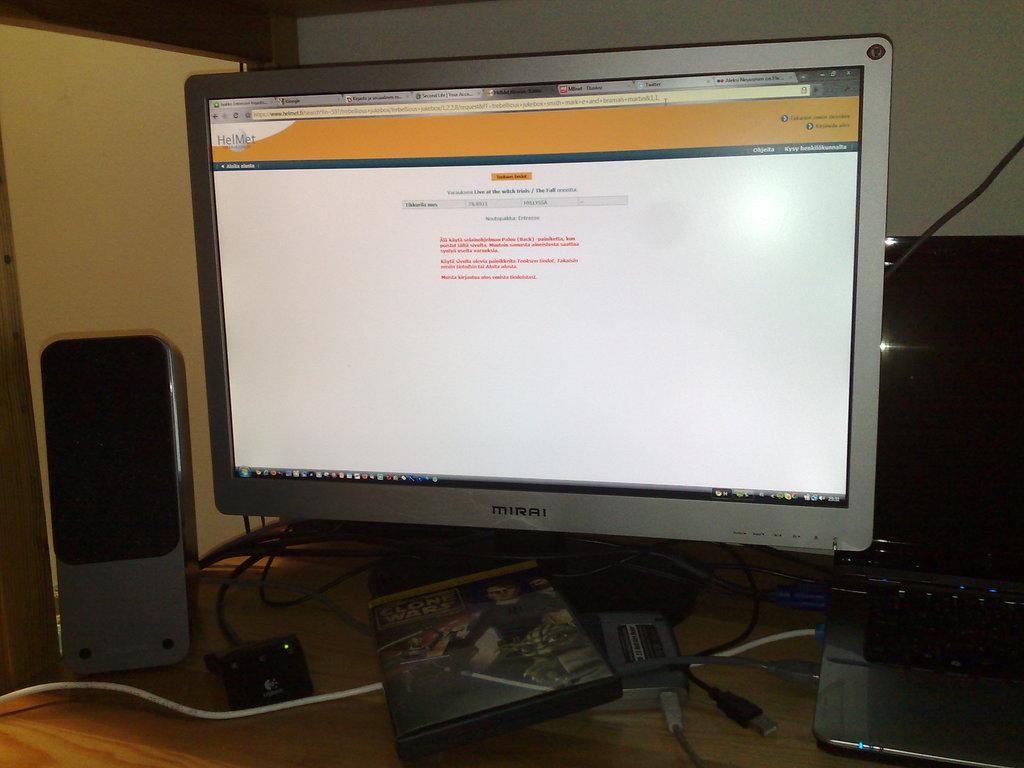What electronic device is present in the image? There is a monitor in the image. What is being displayed on the monitor? There are tabs opened on the monitor, and a website is visible on the screen. What audio device is present in the image? There is a speaker in the image. What type of computer is visible in the image? There is a laptop in the image. Are there any visible connections in the image? Yes, there are wires visible in the image. Can you describe the unspecified object in the image? Unfortunately, the description of the unspecified object is not provided in the facts. What type of yoke is connected to the laptop in the image? There is no yoke present in the image, and therefore no such connection can be observed. What kind of bird can be seen flying across the screen on the monitor? There is no bird visible on the screen or in the image. 